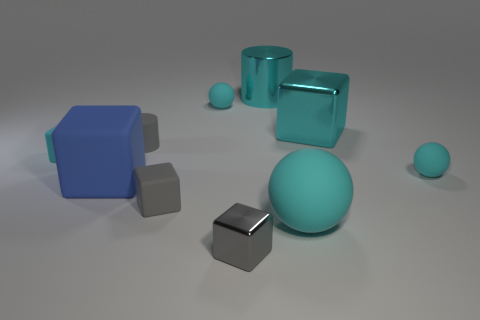Does the gray metallic block have the same size as the gray matte cube?
Provide a succinct answer. Yes. What number of objects are either gray rubber blocks or metal objects that are behind the large cyan rubber sphere?
Your response must be concise. 3. There is a cyan cube that is the same size as the gray matte cylinder; what is its material?
Provide a succinct answer. Rubber. The cube that is both to the left of the cyan cylinder and behind the blue cube is made of what material?
Provide a succinct answer. Rubber. Are there any tiny gray shiny blocks right of the rubber ball that is to the left of the big cyan cylinder?
Your answer should be compact. Yes. There is a object that is both on the left side of the big cyan cylinder and in front of the tiny gray matte block; how big is it?
Provide a short and direct response. Small. What number of purple things are either big metal blocks or rubber spheres?
Ensure brevity in your answer.  0. There is a gray matte thing that is the same size as the gray matte block; what shape is it?
Offer a terse response. Cylinder. What number of other objects are there of the same color as the metal cylinder?
Keep it short and to the point. 5. There is a cyan object that is on the left side of the small gray rubber object that is behind the tiny cyan block; what size is it?
Your response must be concise. Small. 